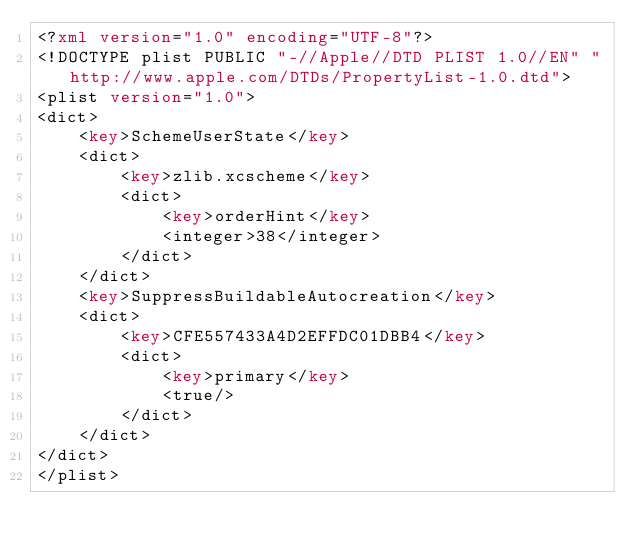Convert code to text. <code><loc_0><loc_0><loc_500><loc_500><_XML_><?xml version="1.0" encoding="UTF-8"?>
<!DOCTYPE plist PUBLIC "-//Apple//DTD PLIST 1.0//EN" "http://www.apple.com/DTDs/PropertyList-1.0.dtd">
<plist version="1.0">
<dict>
	<key>SchemeUserState</key>
	<dict>
		<key>zlib.xcscheme</key>
		<dict>
			<key>orderHint</key>
			<integer>38</integer>
		</dict>
	</dict>
	<key>SuppressBuildableAutocreation</key>
	<dict>
		<key>CFE557433A4D2EFFDC01DBB4</key>
		<dict>
			<key>primary</key>
			<true/>
		</dict>
	</dict>
</dict>
</plist>
</code> 